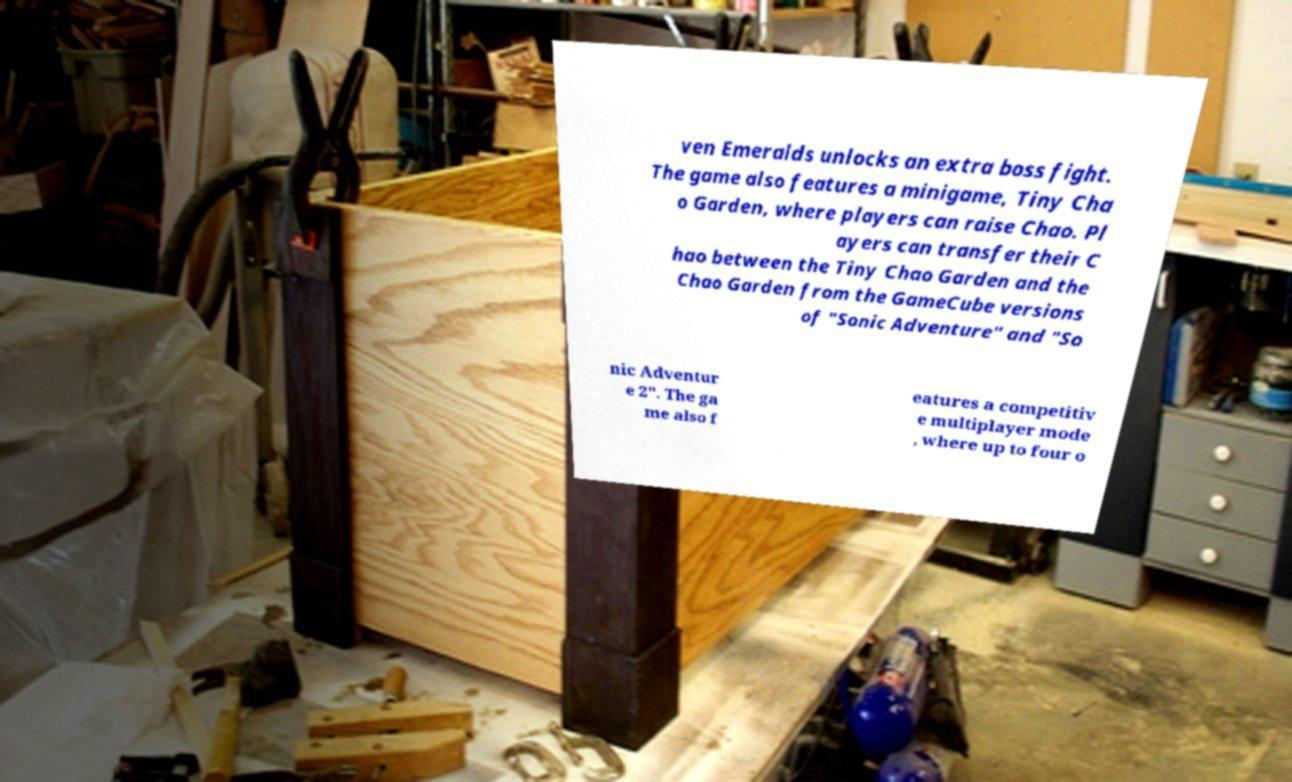Could you assist in decoding the text presented in this image and type it out clearly? ven Emeralds unlocks an extra boss fight. The game also features a minigame, Tiny Cha o Garden, where players can raise Chao. Pl ayers can transfer their C hao between the Tiny Chao Garden and the Chao Garden from the GameCube versions of "Sonic Adventure" and "So nic Adventur e 2". The ga me also f eatures a competitiv e multiplayer mode , where up to four o 